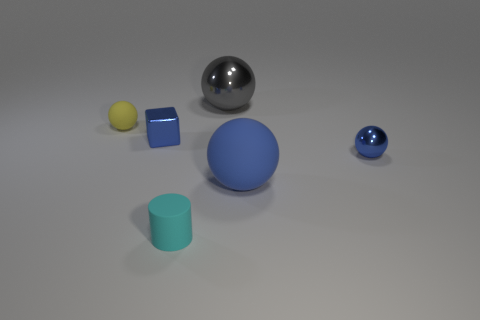Add 2 small purple metal blocks. How many objects exist? 8 Subtract all yellow spheres. How many spheres are left? 3 Subtract all blocks. How many objects are left? 5 Subtract 2 spheres. How many spheres are left? 2 Subtract all gray cylinders. How many purple blocks are left? 0 Subtract all tiny cylinders. Subtract all small balls. How many objects are left? 3 Add 1 tiny blue blocks. How many tiny blue blocks are left? 2 Add 6 big brown balls. How many big brown balls exist? 6 Subtract 0 brown cylinders. How many objects are left? 6 Subtract all cyan spheres. Subtract all gray blocks. How many spheres are left? 4 